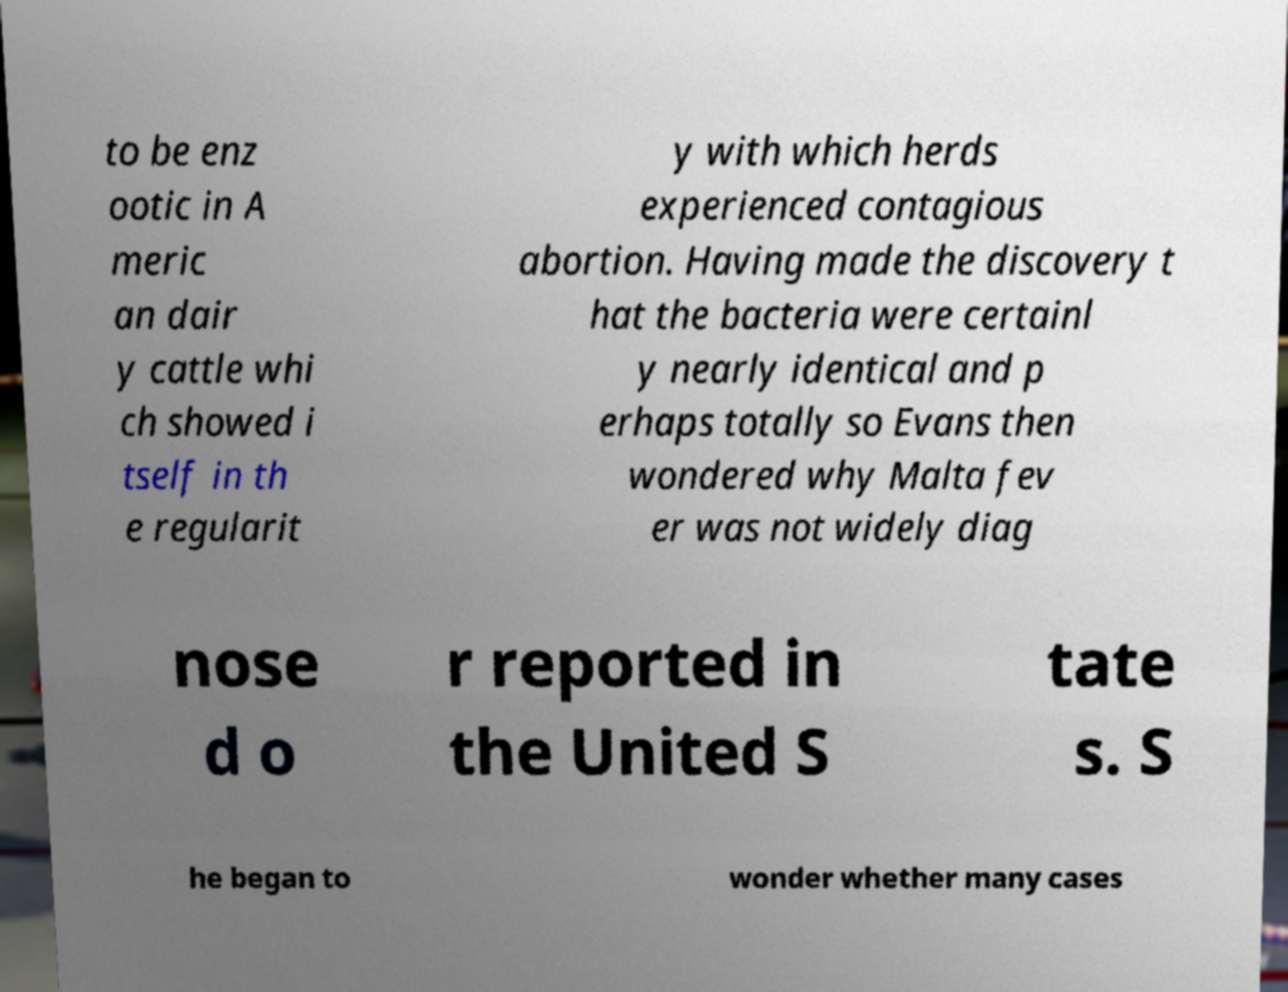Please read and relay the text visible in this image. What does it say? to be enz ootic in A meric an dair y cattle whi ch showed i tself in th e regularit y with which herds experienced contagious abortion. Having made the discovery t hat the bacteria were certainl y nearly identical and p erhaps totally so Evans then wondered why Malta fev er was not widely diag nose d o r reported in the United S tate s. S he began to wonder whether many cases 